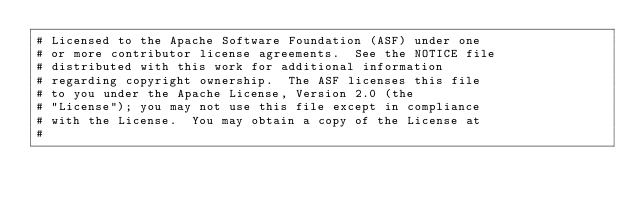<code> <loc_0><loc_0><loc_500><loc_500><_Cython_># Licensed to the Apache Software Foundation (ASF) under one
# or more contributor license agreements.  See the NOTICE file
# distributed with this work for additional information
# regarding copyright ownership.  The ASF licenses this file
# to you under the Apache License, Version 2.0 (the
# "License"); you may not use this file except in compliance
# with the License.  You may obtain a copy of the License at
#</code> 